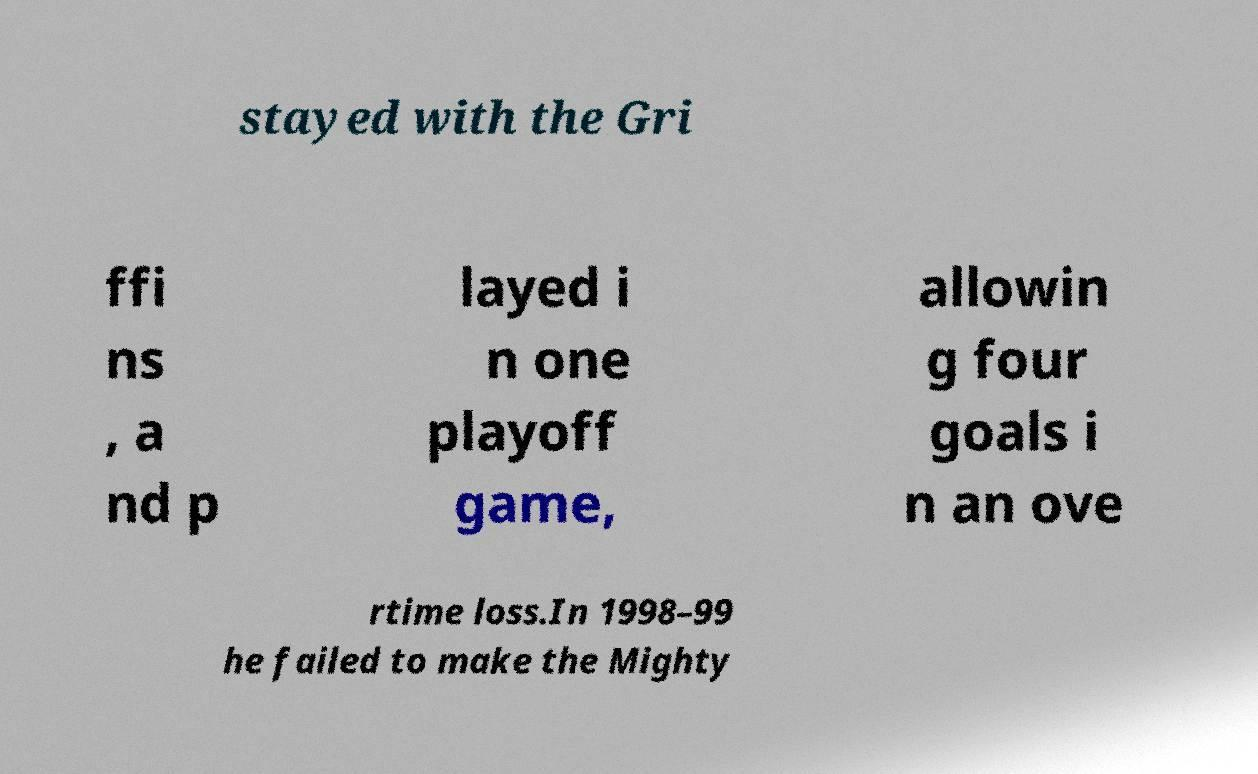Can you accurately transcribe the text from the provided image for me? stayed with the Gri ffi ns , a nd p layed i n one playoff game, allowin g four goals i n an ove rtime loss.In 1998–99 he failed to make the Mighty 